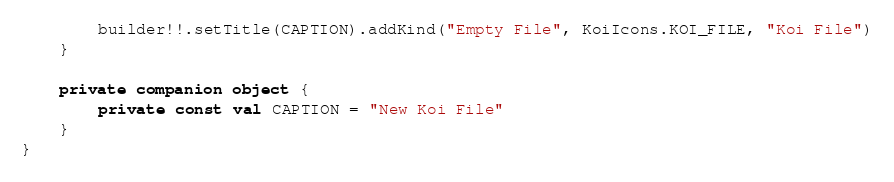<code> <loc_0><loc_0><loc_500><loc_500><_Kotlin_>        builder!!.setTitle(CAPTION).addKind("Empty File", KoiIcons.KOI_FILE, "Koi File")
    }

    private companion object {
        private const val CAPTION = "New Koi File"
    }
}</code> 